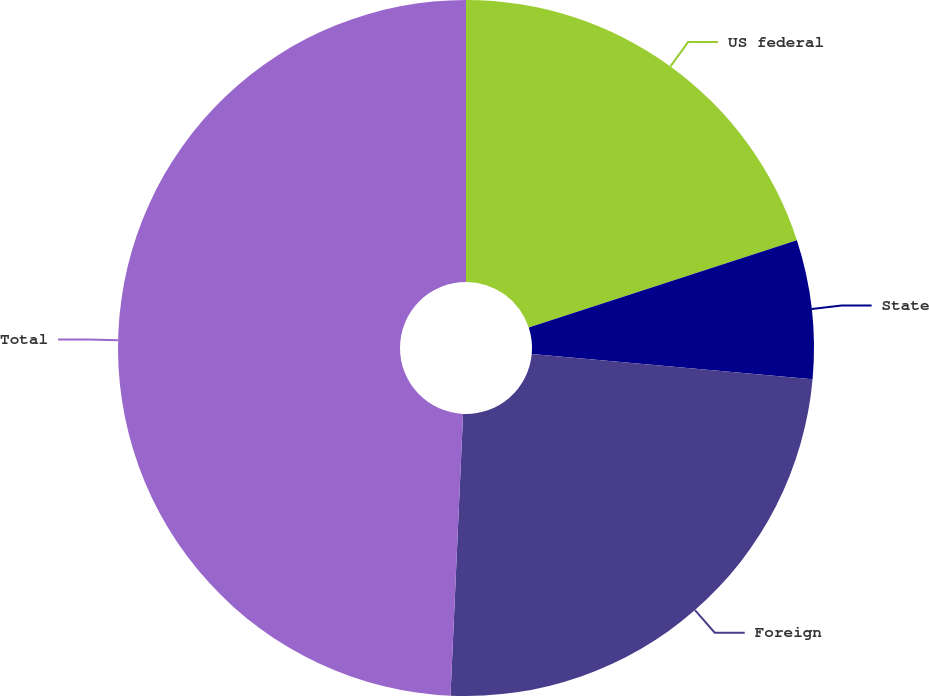Convert chart to OTSL. <chart><loc_0><loc_0><loc_500><loc_500><pie_chart><fcel>US federal<fcel>State<fcel>Foreign<fcel>Total<nl><fcel>19.99%<fcel>6.44%<fcel>24.28%<fcel>49.29%<nl></chart> 